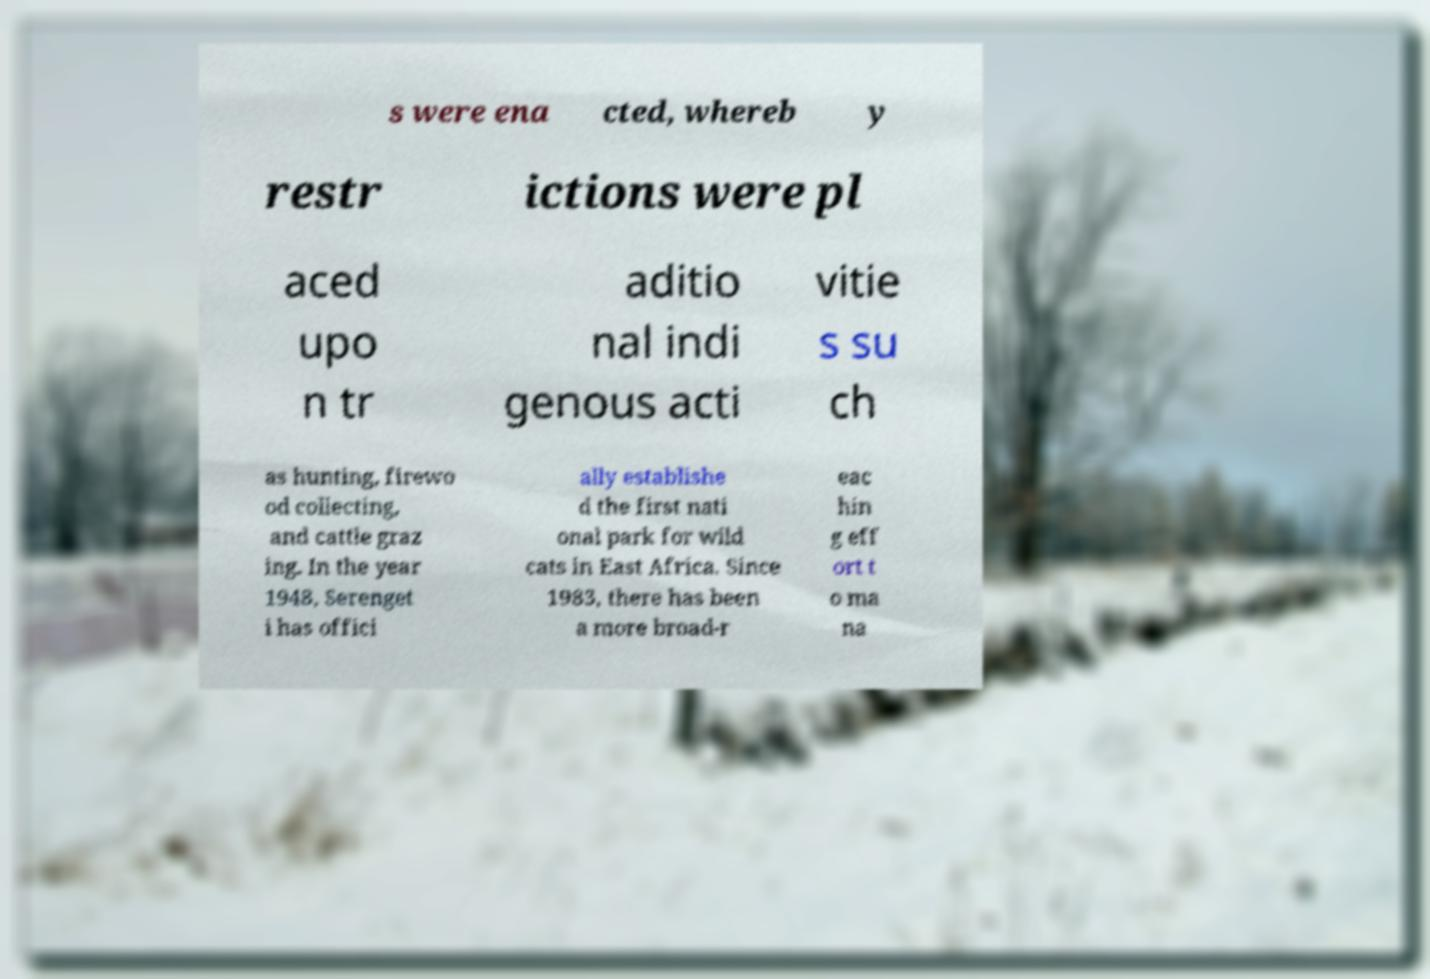There's text embedded in this image that I need extracted. Can you transcribe it verbatim? s were ena cted, whereb y restr ictions were pl aced upo n tr aditio nal indi genous acti vitie s su ch as hunting, firewo od collecting, and cattle graz ing. In the year 1948, Serenget i has offici ally establishe d the first nati onal park for wild cats in East Africa. Since 1983, there has been a more broad-r eac hin g eff ort t o ma na 